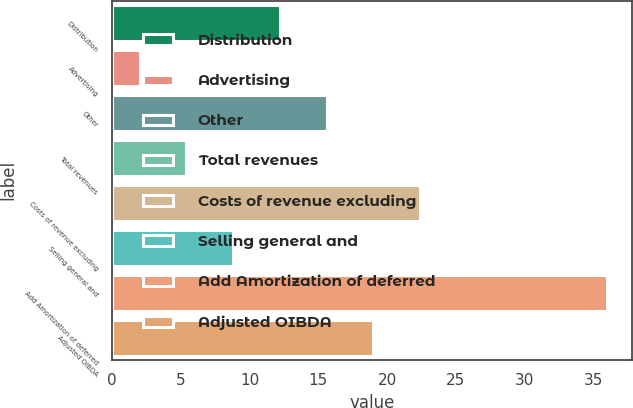<chart> <loc_0><loc_0><loc_500><loc_500><bar_chart><fcel>Distribution<fcel>Advertising<fcel>Other<fcel>Total revenues<fcel>Costs of revenue excluding<fcel>Selling general and<fcel>Add Amortization of deferred<fcel>Adjusted OIBDA<nl><fcel>12.2<fcel>2<fcel>15.6<fcel>5.4<fcel>22.4<fcel>8.8<fcel>36<fcel>19<nl></chart> 